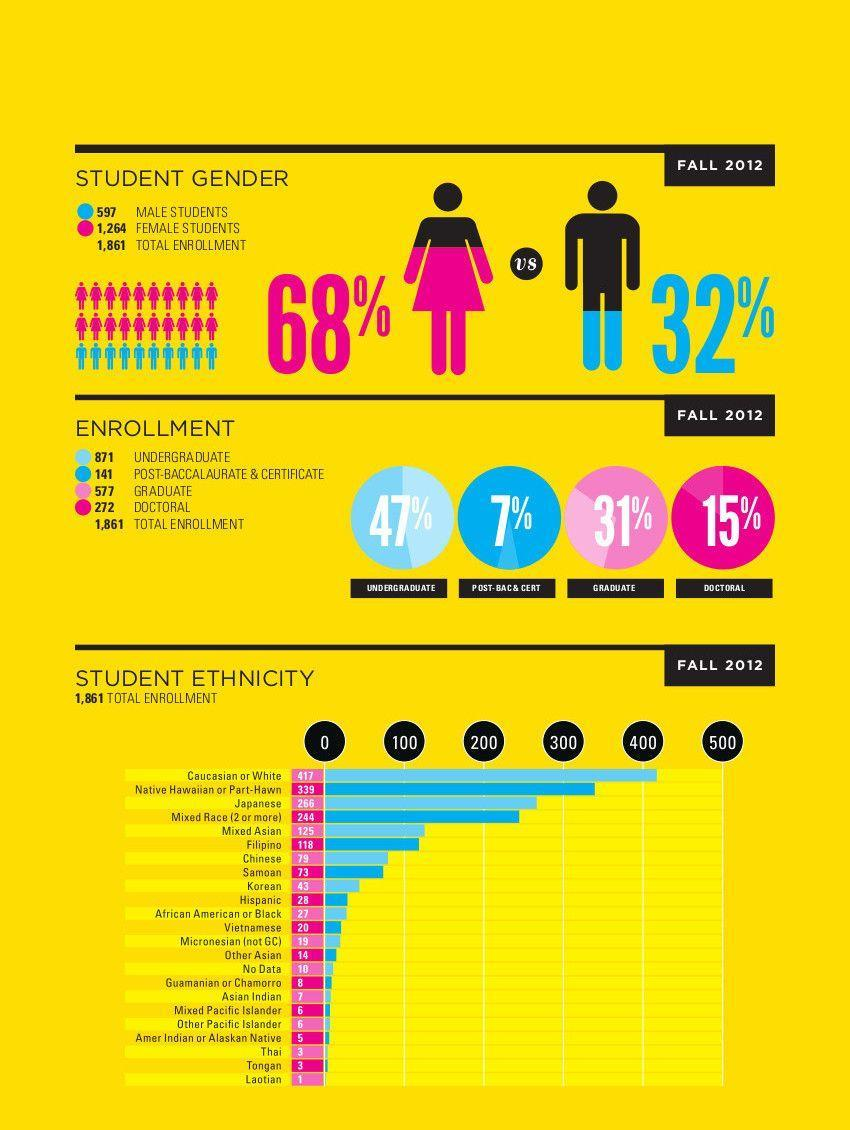What percentage of students enrolled for a doctoral degree in fall 2012?
Answer the question with a short phrase. 15% What is the percentage of female students enrolled during the fall 2012? 68% How many Asian Indian students enrolled during the fall 2012? 7 What is the percentage of male students enrolled during the fall 2012? 32% Which degree do the majority of the students enrolled during fall 2012? UNDERGRADUATE What percentage of students enrolled for a graduate degree during fall 2012? 31% 